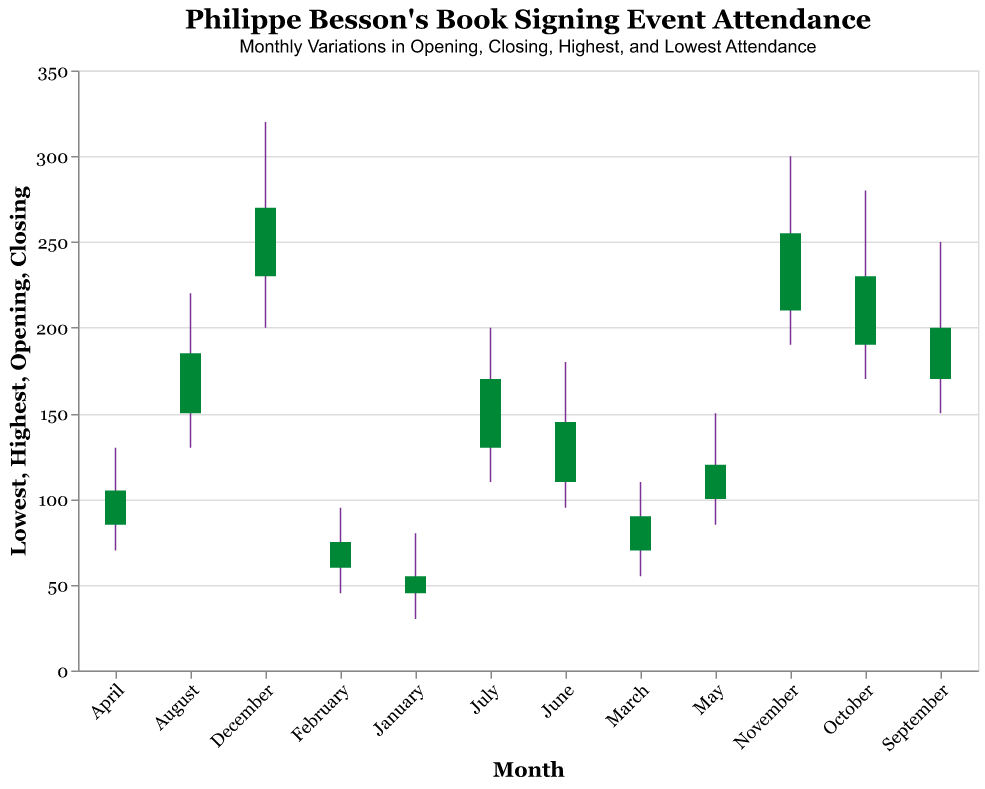What is the title of the figure? The title is usually located at the top of the figure. It is written in a larger and often bold font to stand out as the main heading.
Answer: Philippe Besson's Book Signing Event Attendance Which month had the highest peak attendance? The highest peak attendance can be observed from the "Highest" values along the vertical axis. By scanning through the peaks, the highest value can be seen in December.
Answer: December What was the closing attendance in March? The closing attendance for each month is indicated by the end of the green bar. In March, the closing attendance value is marked at 90 on the vertical axis.
Answer: 90 Compare the opening attendance in January and July. Which one had a higher opening attendance? To compare the opening attendances, look at the values at the bottom of the green bar for each month. January has an opening attendance of 45 and July has 130, so July is higher.
Answer: July Calculate the average opening attendance for the first half of the year. Add the opening values from January to June (45 + 60 + 70 + 85 + 100 + 110) and divide by 6. (45 + 60 + 70 + 85 + 100 + 110) = 470; 470 / 6 = 78.3
Answer: 78.3 Between which two consecutive months was the increase in closing attendance the greatest? To find the increase in closing attendance between consecutive months, subtract the closing attendance of one month from the closing attendance of the next month and compare these values. Check all pairs from January to December. The biggest jump is from June (145) to July (170), an increase of 25.
Answer: June and July Which month had the smallest range in attendance (difference between highest and lowest values)? The range of attendance for each month is calculated by subtracting the lowest value from the highest value. January has a range of (80 - 30) = 50; Continue this calculation for each month, and identify the month with the smallest range. February has a range of (95 - 45) = 50, and so on. May has a range of (150 - 85) = 65, and continue until December. The month with the smallest range is January (50).
Answer: January What trends can you observe in attendance from January to December? By analyzing the general direction of the opening, closing, highest, and lowest attendance values over the months, notice a consistent increase in all values from January to December.
Answer: Increasing trend 